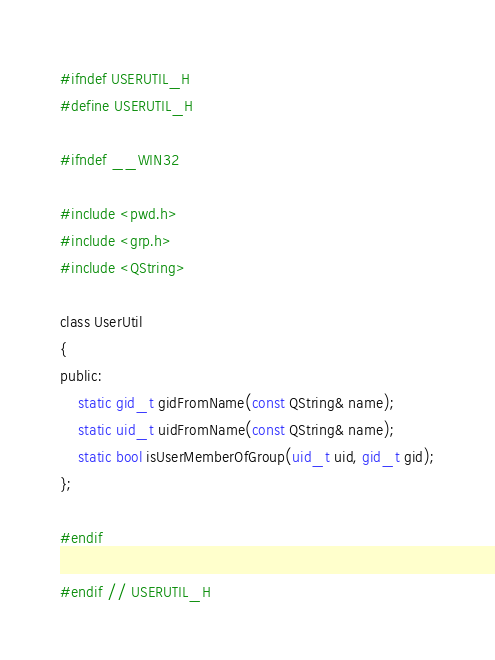<code> <loc_0><loc_0><loc_500><loc_500><_C_>#ifndef USERUTIL_H
#define USERUTIL_H

#ifndef __WIN32

#include <pwd.h>
#include <grp.h>
#include <QString>

class UserUtil
{
public:
    static gid_t gidFromName(const QString& name);
    static uid_t uidFromName(const QString& name);
    static bool isUserMemberOfGroup(uid_t uid, gid_t gid);
};

#endif

#endif // USERUTIL_H
</code> 